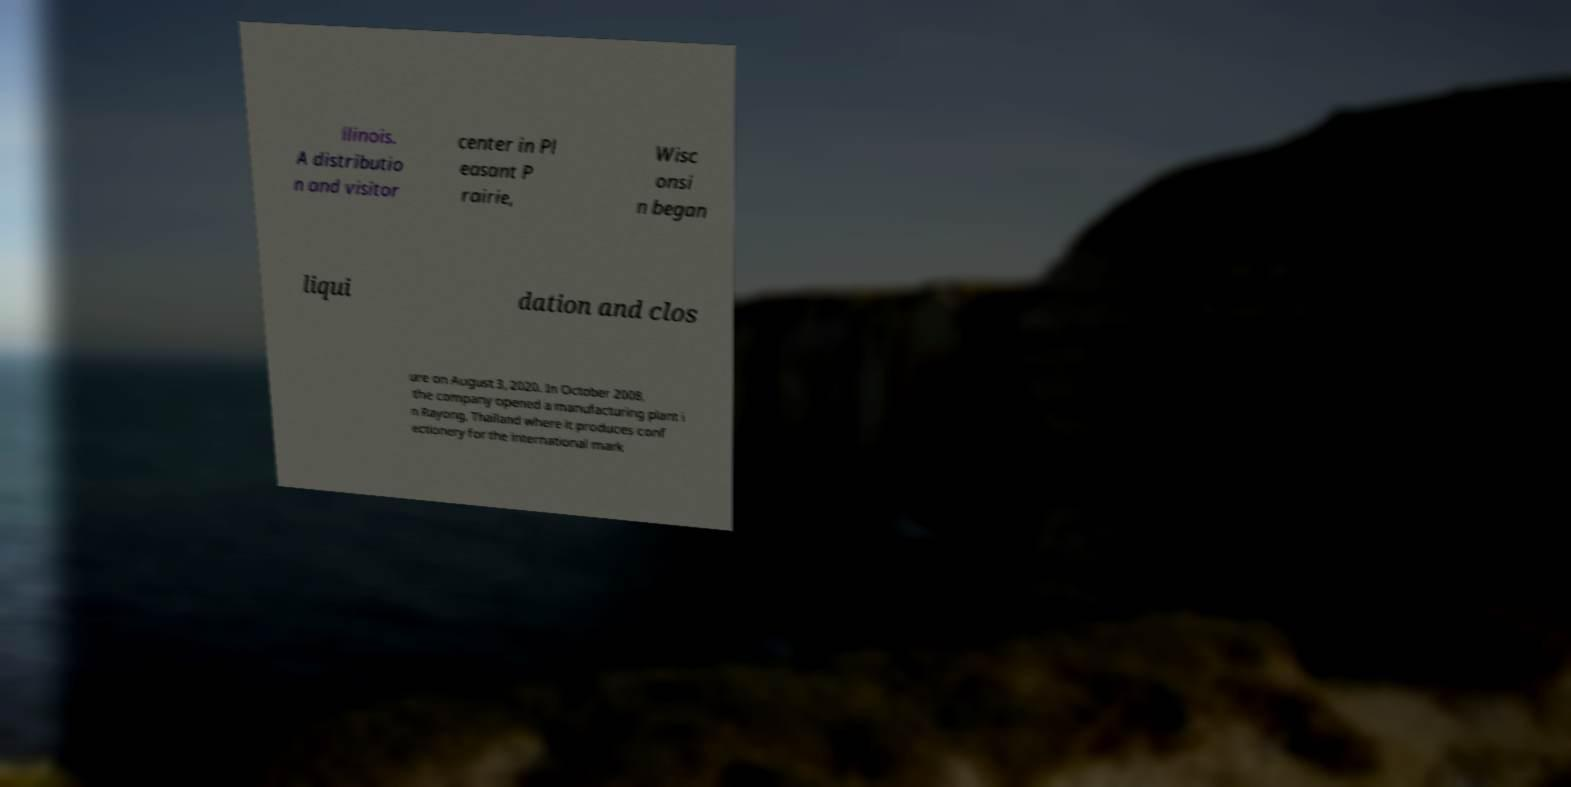Could you assist in decoding the text presented in this image and type it out clearly? llinois. A distributio n and visitor center in Pl easant P rairie, Wisc onsi n began liqui dation and clos ure on August 3, 2020. In October 2008, the company opened a manufacturing plant i n Rayong, Thailand where it produces conf ectionery for the international mark 